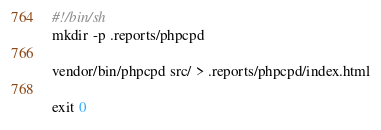<code> <loc_0><loc_0><loc_500><loc_500><_Bash_>#!/bin/sh
mkdir -p .reports/phpcpd

vendor/bin/phpcpd src/ > .reports/phpcpd/index.html

exit 0</code> 